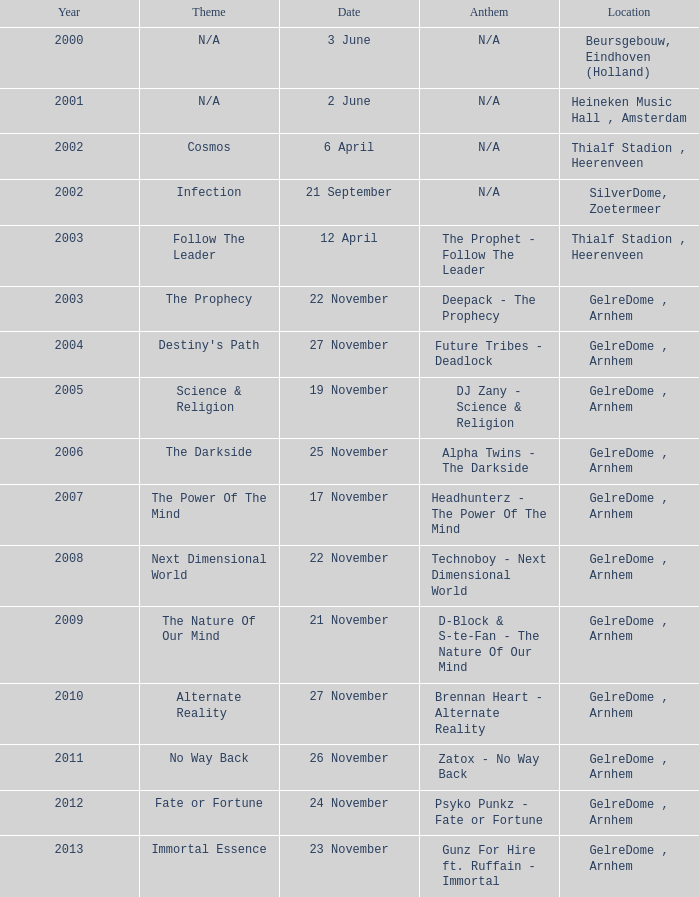What is the earliest year it was located in gelredome, arnhem, and a Anthem of technoboy - next dimensional world? 2008.0. 